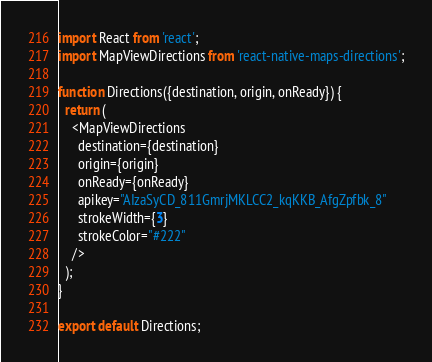Convert code to text. <code><loc_0><loc_0><loc_500><loc_500><_JavaScript_>import React from 'react';
import MapViewDirections from 'react-native-maps-directions';

function Directions({destination, origin, onReady}) {
  return (
    <MapViewDirections
      destination={destination}
      origin={origin}
      onReady={onReady}
      apikey="AIzaSyCD_811GmrjMKLCC2_kqKKB_AfgZpfbk_8"
      strokeWidth={3}
      strokeColor="#222"
    />
  );
}

export default Directions;
</code> 